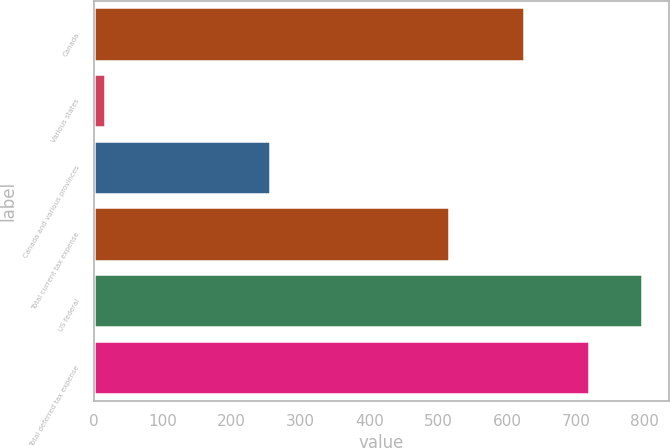Convert chart. <chart><loc_0><loc_0><loc_500><loc_500><bar_chart><fcel>Canada<fcel>Various states<fcel>Canada and various provinces<fcel>Total current tax expense<fcel>US federal<fcel>Total deferred tax expense<nl><fcel>625<fcel>16<fcel>256<fcel>516<fcel>795.5<fcel>719<nl></chart> 